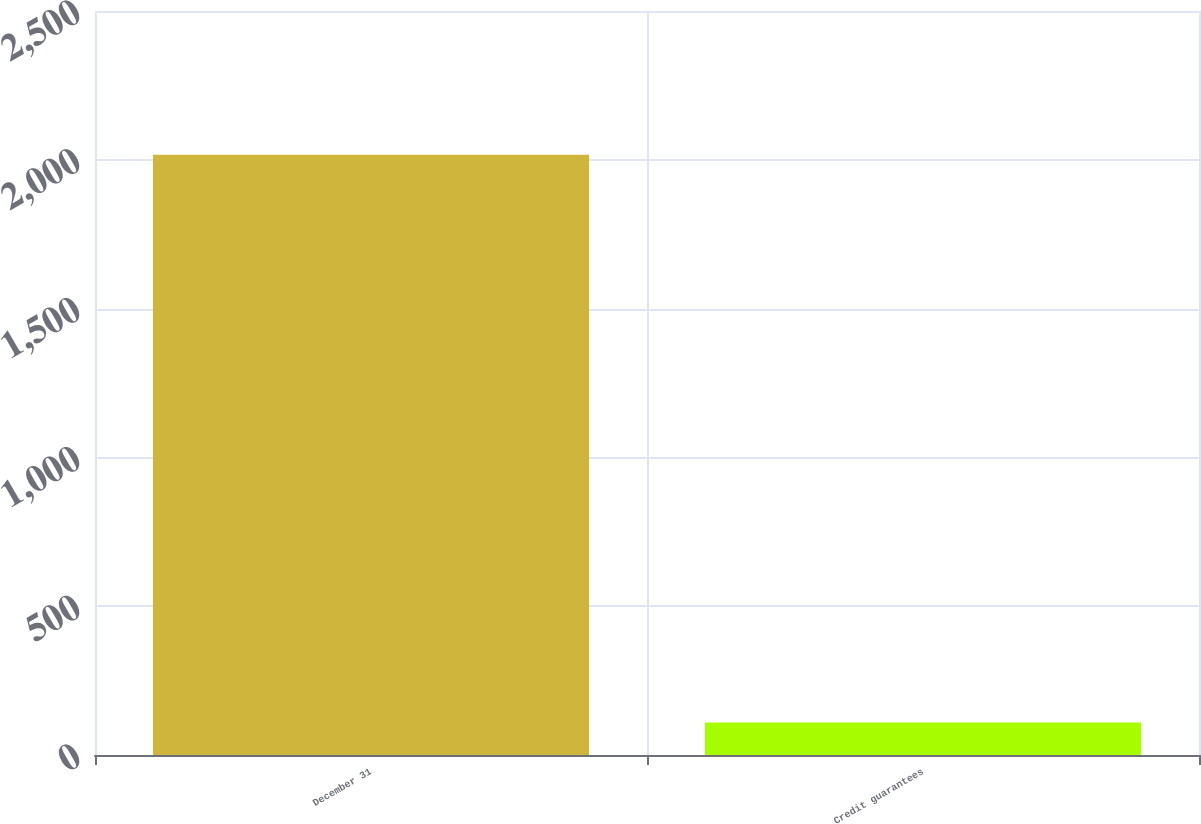<chart> <loc_0><loc_0><loc_500><loc_500><bar_chart><fcel>December 31<fcel>Credit guarantees<nl><fcel>2017<fcel>109<nl></chart> 